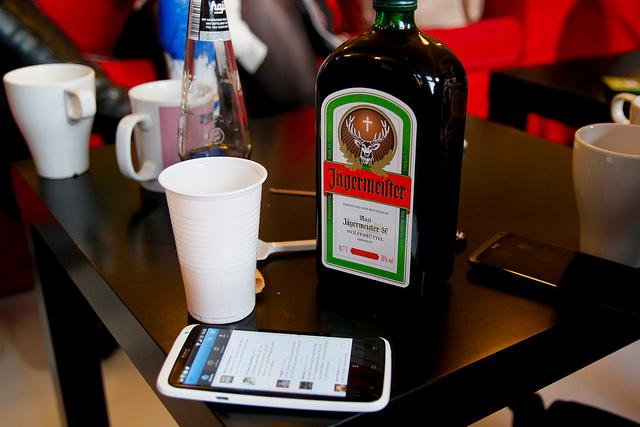What athlete has a last name that is similar to the name on the bottle? Please explain your reasoning. jaromir jagr. The letters are the same in the first part 